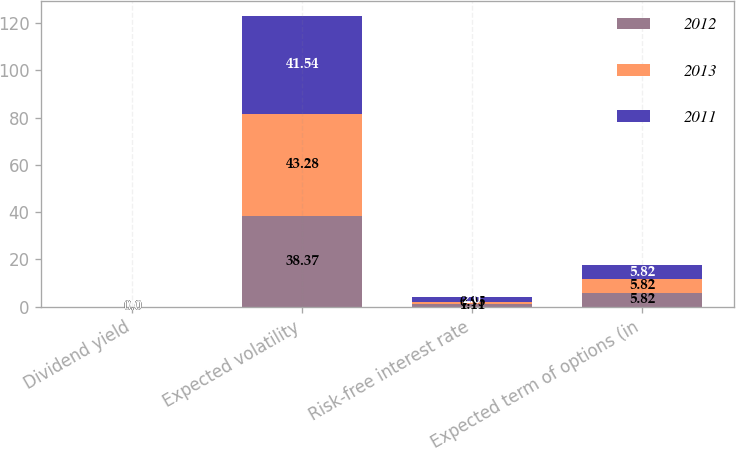Convert chart. <chart><loc_0><loc_0><loc_500><loc_500><stacked_bar_chart><ecel><fcel>Dividend yield<fcel>Expected volatility<fcel>Risk-free interest rate<fcel>Expected term of options (in<nl><fcel>2012<fcel>0<fcel>38.37<fcel>1.11<fcel>5.82<nl><fcel>2013<fcel>0<fcel>43.28<fcel>0.95<fcel>5.82<nl><fcel>2011<fcel>0<fcel>41.54<fcel>2<fcel>5.82<nl></chart> 